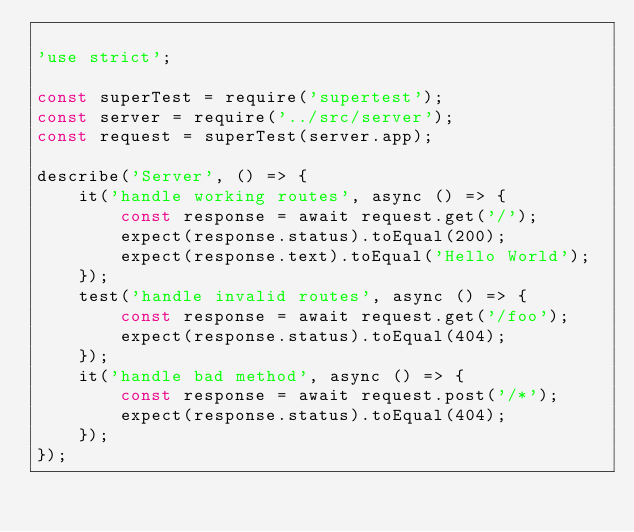Convert code to text. <code><loc_0><loc_0><loc_500><loc_500><_JavaScript_>
'use strict';

const superTest = require('supertest');
const server = require('../src/server');
const request = superTest(server.app);

describe('Server', () => {
    it('handle working routes', async () => {
        const response = await request.get('/');
        expect(response.status).toEqual(200);
        expect(response.text).toEqual('Hello World');
    });
    test('handle invalid routes', async () => {
        const response = await request.get('/foo');
        expect(response.status).toEqual(404);
    });
    it('handle bad method', async () => {
        const response = await request.post('/*');
        expect(response.status).toEqual(404);
    });
});</code> 